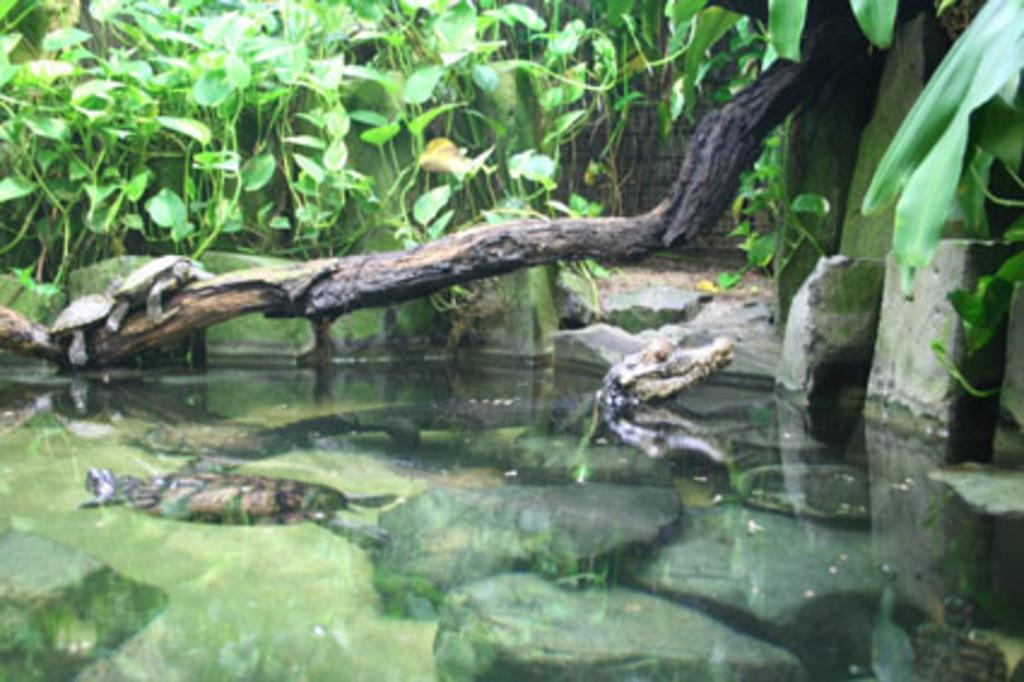What is the primary element in the image? There is water in the image. What other objects or features can be seen in the image? There are rocks, water animals, a branch, two tortoises, and leaves present in the image. Can you describe the water animals in the image? The water animals in the image are not specified, but they are present in the water. What type of vegetation is present in the image? Leaves are present in the image. What is the shape of the heart in the image? There is no heart present in the image. 